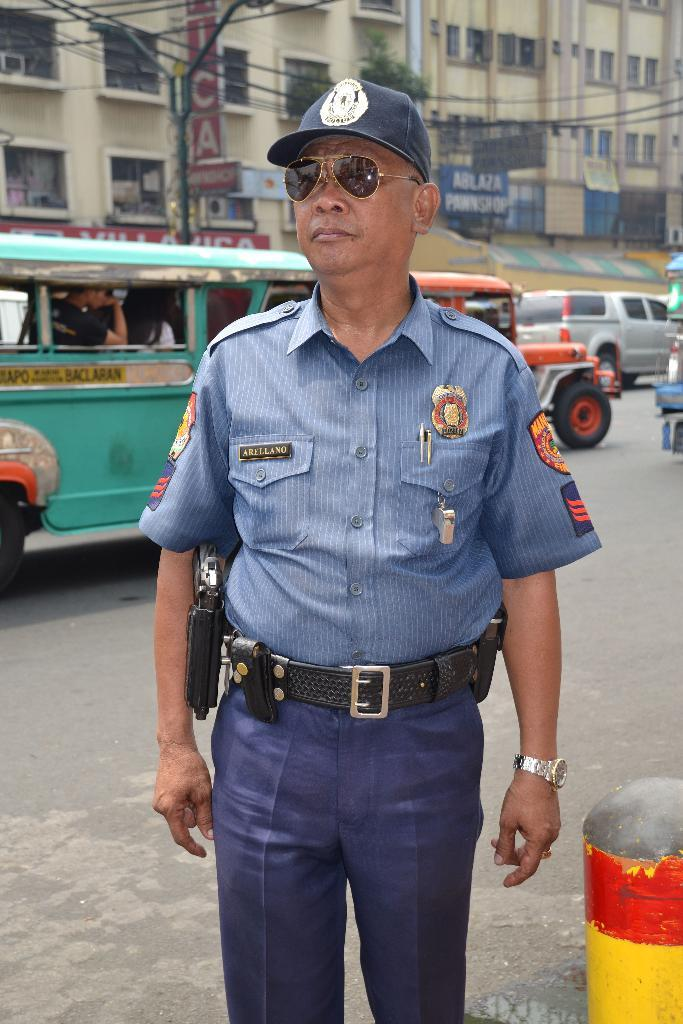What is the person in the image doing? The person is standing on the road. Where is the person standing in relation to the road? The person is standing on the back side of the road. What else can be seen on the road in the image? There are vehicles moving on the road. What can be seen in the background of the image? There are buildings visible in the image. What type of chicken can be seen folding its wings in the image? There is no chicken present in the image, and therefore no such activity can be observed. 